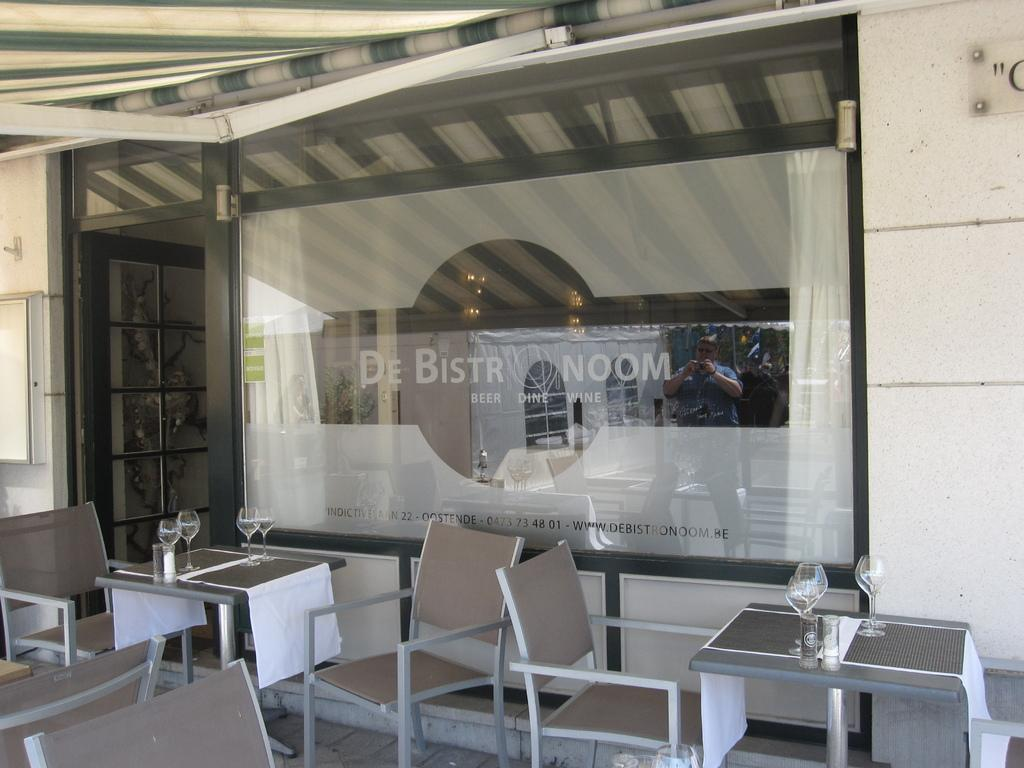<image>
Provide a brief description of the given image. Classy french restaurant which prominently features beer and wine. 